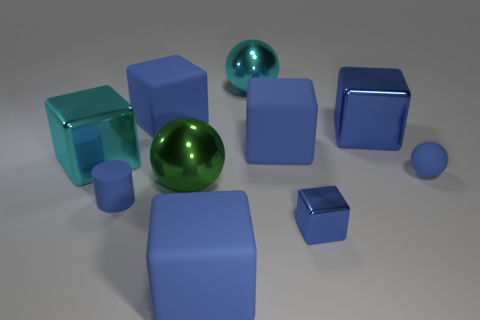How many blue blocks must be subtracted to get 3 blue blocks? 2 Subtract all big cyan cubes. How many cubes are left? 5 Subtract all blue balls. How many balls are left? 2 Subtract 1 balls. How many balls are left? 2 Subtract all cylinders. How many objects are left? 9 Subtract all yellow cubes. How many blue spheres are left? 1 Subtract all small rubber balls. Subtract all cyan rubber cubes. How many objects are left? 9 Add 3 blue rubber cylinders. How many blue rubber cylinders are left? 4 Add 8 large balls. How many large balls exist? 10 Subtract 0 brown cylinders. How many objects are left? 10 